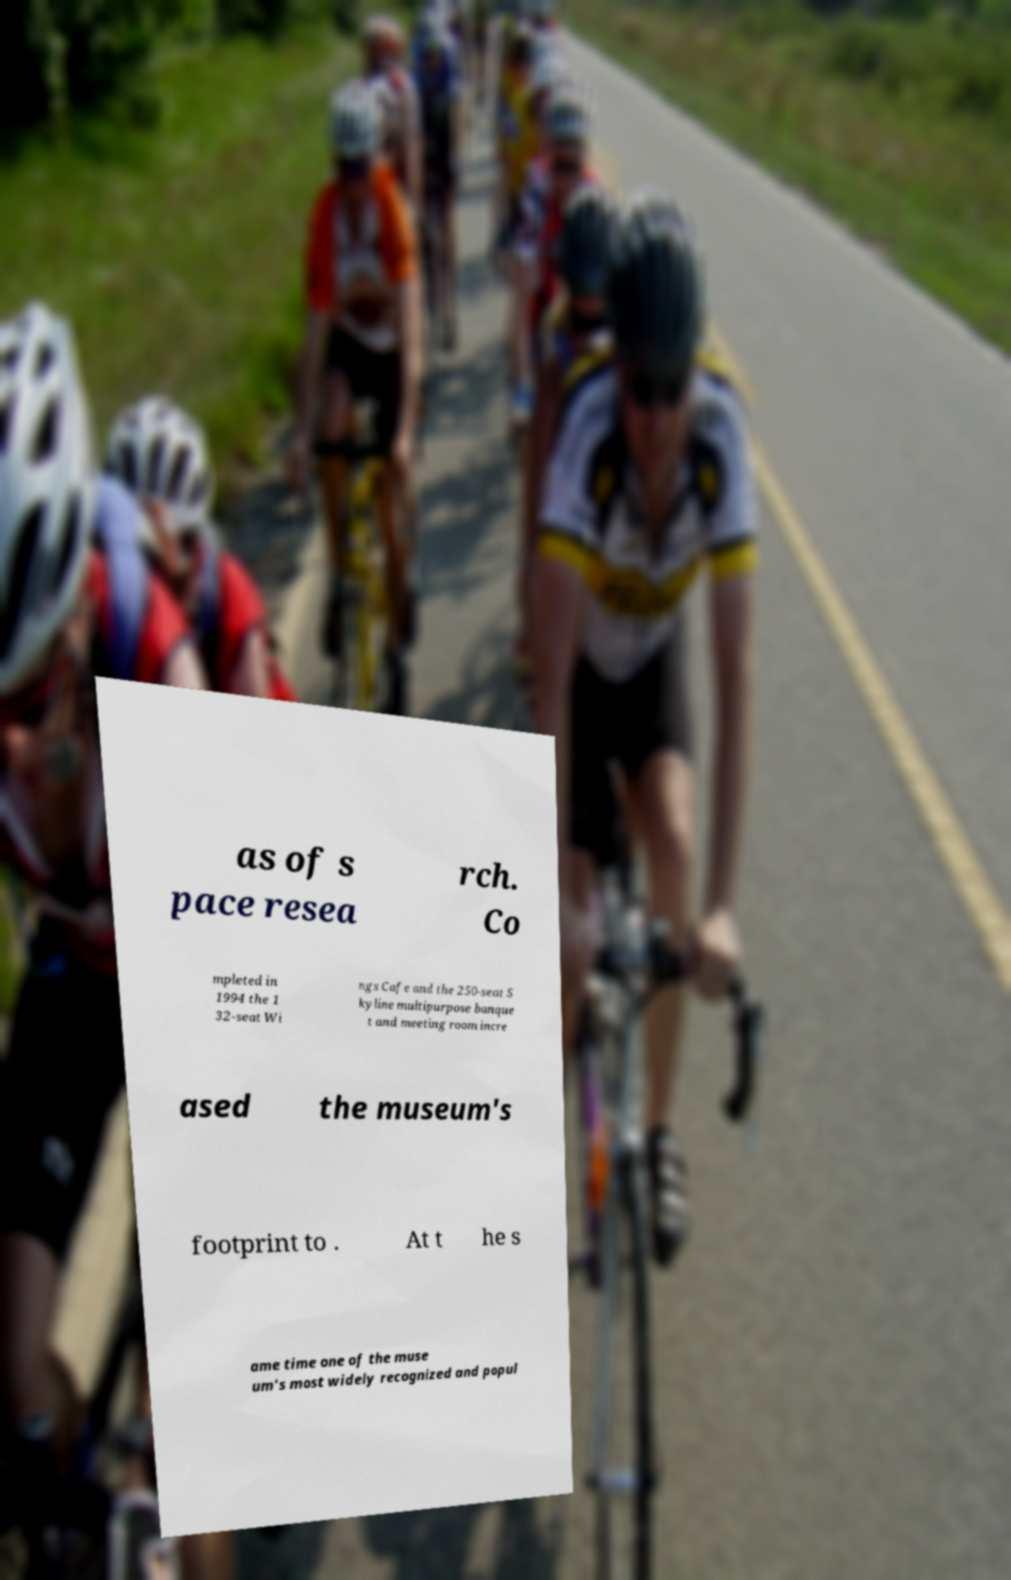There's text embedded in this image that I need extracted. Can you transcribe it verbatim? as of s pace resea rch. Co mpleted in 1994 the 1 32-seat Wi ngs Cafe and the 250-seat S kyline multipurpose banque t and meeting room incre ased the museum's footprint to . At t he s ame time one of the muse um's most widely recognized and popul 